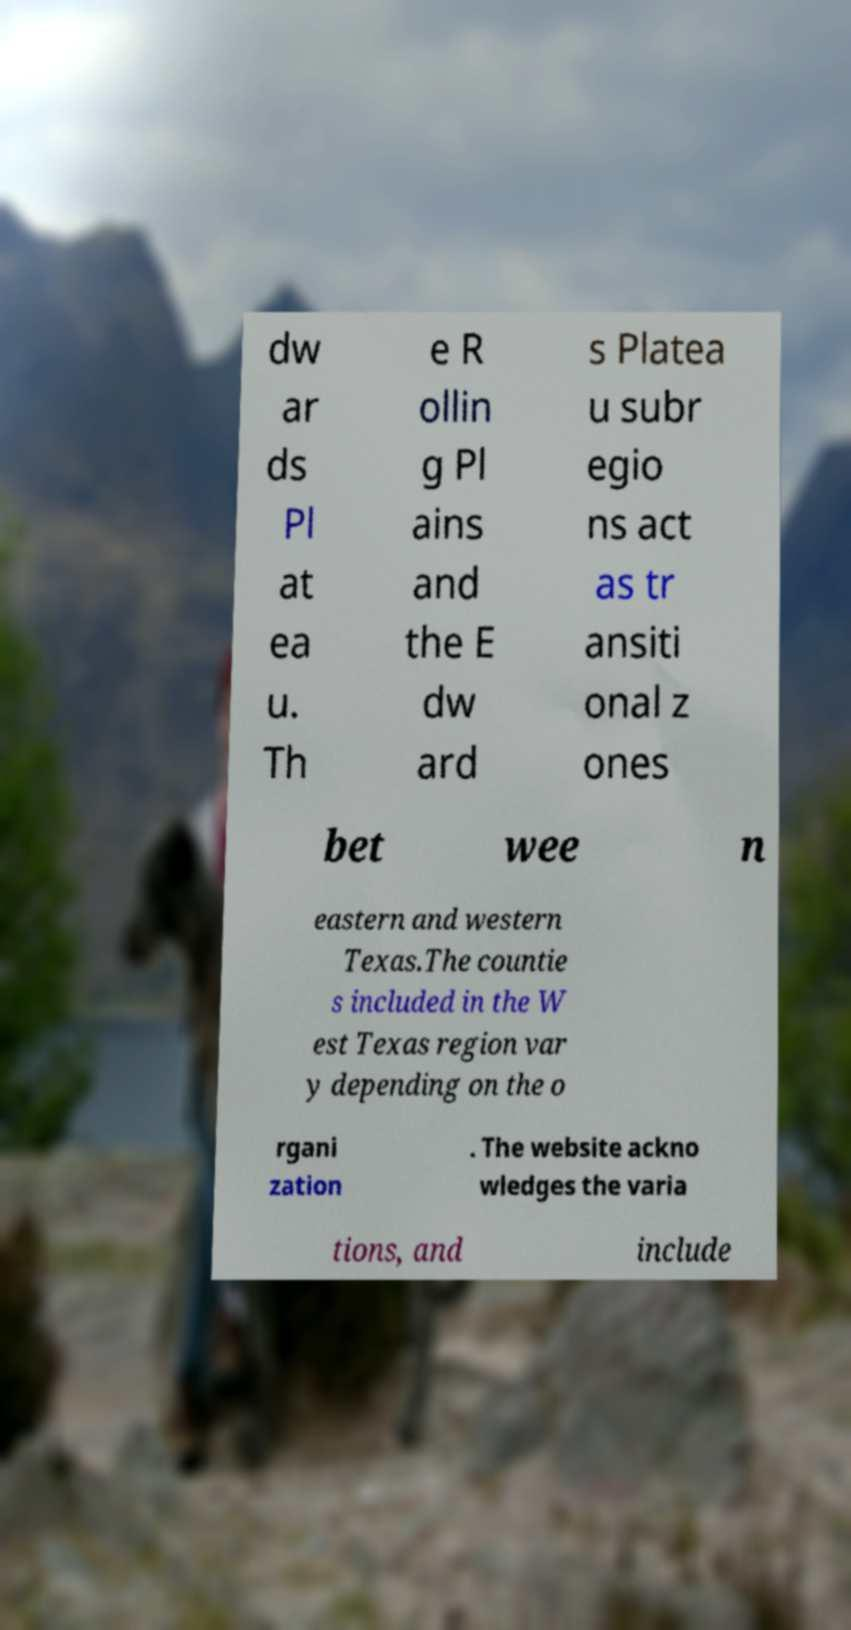For documentation purposes, I need the text within this image transcribed. Could you provide that? dw ar ds Pl at ea u. Th e R ollin g Pl ains and the E dw ard s Platea u subr egio ns act as tr ansiti onal z ones bet wee n eastern and western Texas.The countie s included in the W est Texas region var y depending on the o rgani zation . The website ackno wledges the varia tions, and include 